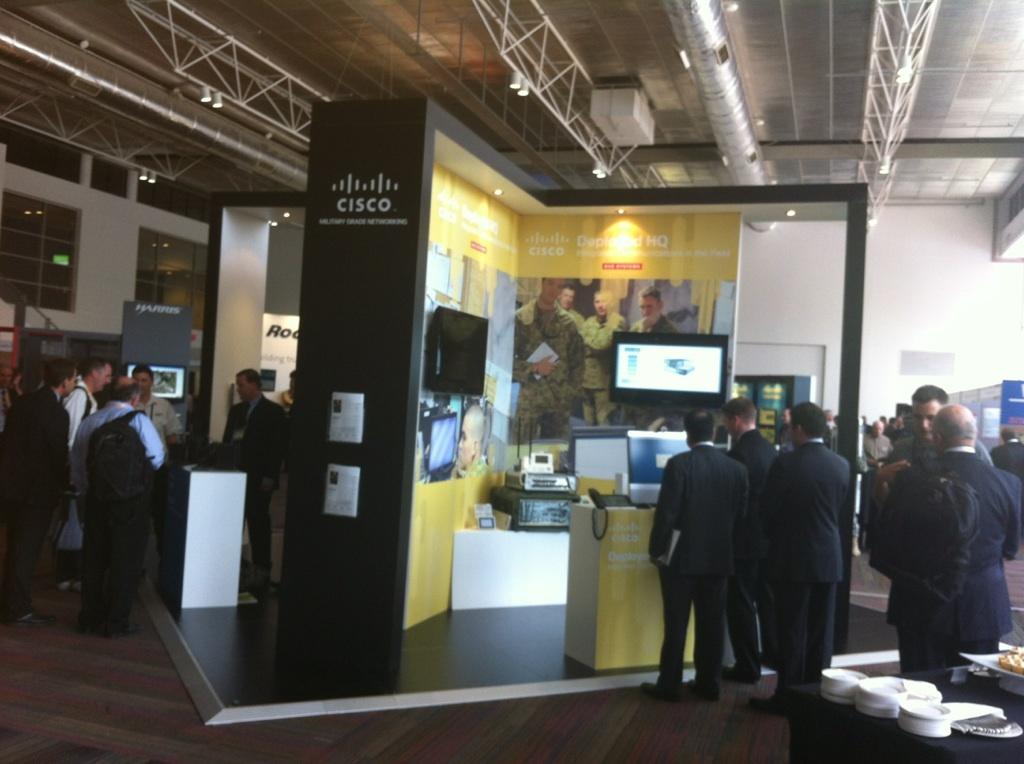Describe this image in one or two sentences. In this image we can see a group of persons and among them there are few persons carrying backpacks. Behind the persons we can see the electronic gadgets and banners. On the banners we can see the text and images. In the background, we can see the wall. At the top we can see the roof and the lights. On the left side, we can see glasses on the wall. In the bottom right we can see few objects on a table. 